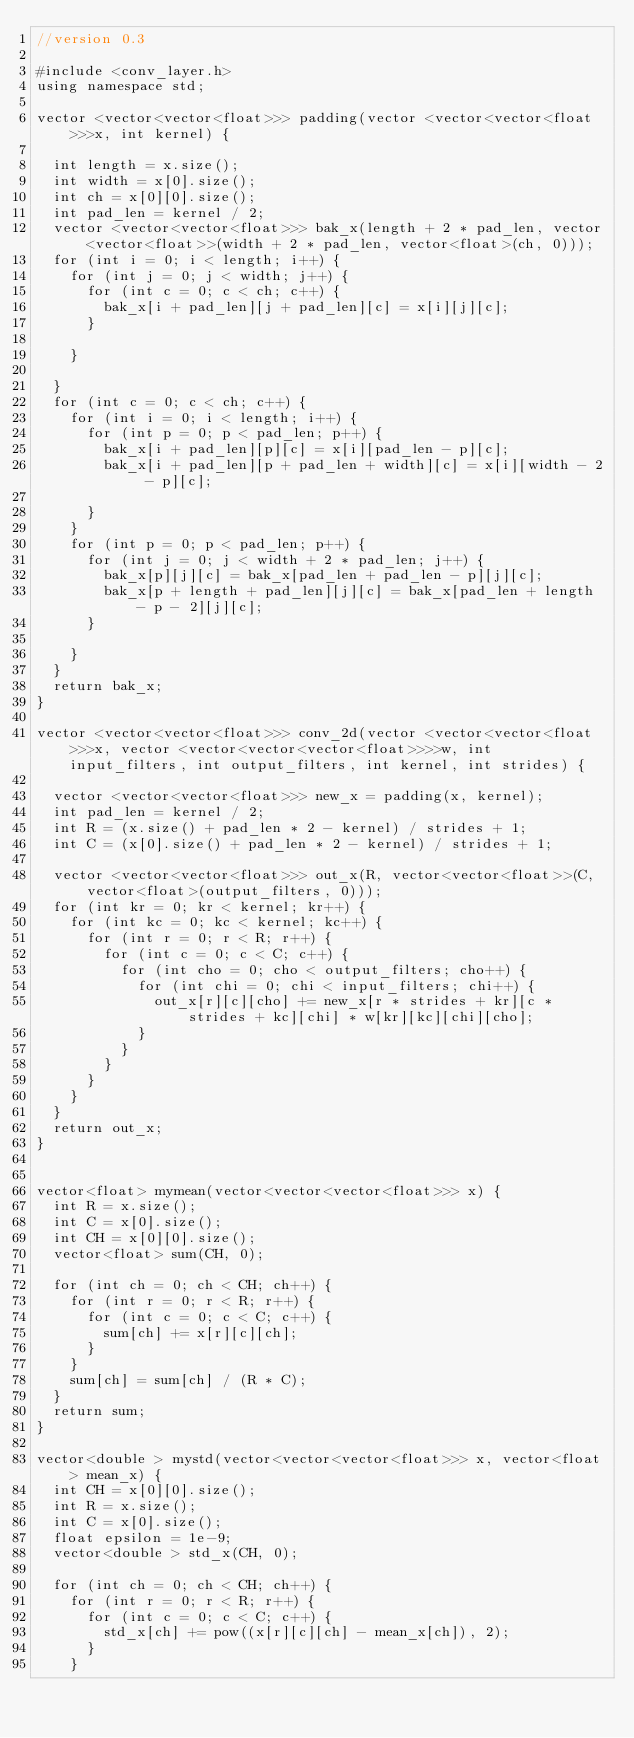Convert code to text. <code><loc_0><loc_0><loc_500><loc_500><_C++_>//version 0.3

#include <conv_layer.h>
using namespace std;

vector <vector<vector<float>>> padding(vector <vector<vector<float>>>x, int kernel) {

	int length = x.size();
	int width = x[0].size();
	int ch = x[0][0].size();
	int pad_len = kernel / 2;
	vector <vector<vector<float>>> bak_x(length + 2 * pad_len, vector<vector<float>>(width + 2 * pad_len, vector<float>(ch, 0)));
	for (int i = 0; i < length; i++) {
		for (int j = 0; j < width; j++) {
			for (int c = 0; c < ch; c++) {
				bak_x[i + pad_len][j + pad_len][c] = x[i][j][c];
			}

		}

	}
	for (int c = 0; c < ch; c++) {
		for (int i = 0; i < length; i++) {
			for (int p = 0; p < pad_len; p++) {
				bak_x[i + pad_len][p][c] = x[i][pad_len - p][c];
				bak_x[i + pad_len][p + pad_len + width][c] = x[i][width - 2 - p][c];

			}
		}
		for (int p = 0; p < pad_len; p++) {
			for (int j = 0; j < width + 2 * pad_len; j++) {
				bak_x[p][j][c] = bak_x[pad_len + pad_len - p][j][c];
				bak_x[p + length + pad_len][j][c] = bak_x[pad_len + length - p - 2][j][c];
			}

		}
	}
	return bak_x;
}

vector <vector<vector<float>>> conv_2d(vector <vector<vector<float>>>x, vector <vector<vector<vector<float>>>>w, int input_filters, int output_filters, int kernel, int strides) {

	vector <vector<vector<float>>> new_x = padding(x, kernel);
	int pad_len = kernel / 2;
	int R = (x.size() + pad_len * 2 - kernel) / strides + 1;
	int C = (x[0].size() + pad_len * 2 - kernel) / strides + 1;

	vector <vector<vector<float>>> out_x(R, vector<vector<float>>(C, vector<float>(output_filters, 0)));
	for (int kr = 0; kr < kernel; kr++) {
		for (int kc = 0; kc < kernel; kc++) {
			for (int r = 0; r < R; r++) {
				for (int c = 0; c < C; c++) {
					for (int cho = 0; cho < output_filters; cho++) {
						for (int chi = 0; chi < input_filters; chi++) {
							out_x[r][c][cho] += new_x[r * strides + kr][c * strides + kc][chi] * w[kr][kc][chi][cho];
						}
					}
				}
			}
		}
	}
	return out_x;
}


vector<float> mymean(vector<vector<vector<float>>> x) {
	int R = x.size();
	int C = x[0].size();
	int CH = x[0][0].size();
	vector<float> sum(CH, 0);

	for (int ch = 0; ch < CH; ch++) {
		for (int r = 0; r < R; r++) {
			for (int c = 0; c < C; c++) {
				sum[ch] += x[r][c][ch];
			}
		}
		sum[ch] = sum[ch] / (R * C);
	}
	return sum;
}

vector<double > mystd(vector<vector<vector<float>>> x, vector<float> mean_x) {
	int CH = x[0][0].size();
	int R = x.size();
	int C = x[0].size();
	float epsilon = 1e-9;
	vector<double > std_x(CH, 0);

	for (int ch = 0; ch < CH; ch++) {
		for (int r = 0; r < R; r++) {
			for (int c = 0; c < C; c++) {
				std_x[ch] += pow((x[r][c][ch] - mean_x[ch]), 2);
			}
		}</code> 